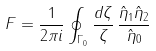Convert formula to latex. <formula><loc_0><loc_0><loc_500><loc_500>F = \frac { 1 } { 2 \pi i } \oint _ { \Gamma _ { 0 } } \frac { d \zeta } { \zeta } \, \frac { \hat { \eta } _ { 1 } \hat { \eta } _ { 2 } } { \hat { \eta } _ { 0 } }</formula> 